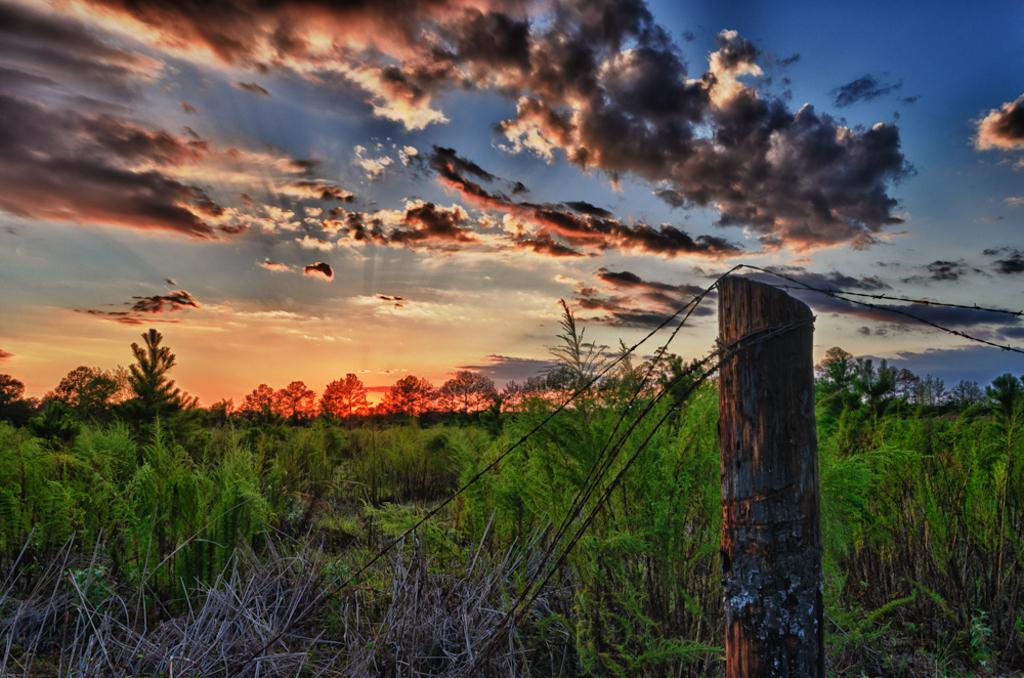What type of material is the bark in the image made of? The wooden bark in the image is made of wood. What other natural elements can be seen in the image? There are plants and trees visible in the image. What is visible in the sky in the image? Clouds are visible in the sky in the image. What type of infrastructure is present in the image? Fencing cables are present in the image. What type of picture is hanging on the wall in the image? There is no mention of a picture hanging on the wall in the image; the facts provided only mention the wooden bark, plants, trees, clouds, and fencing cables. 